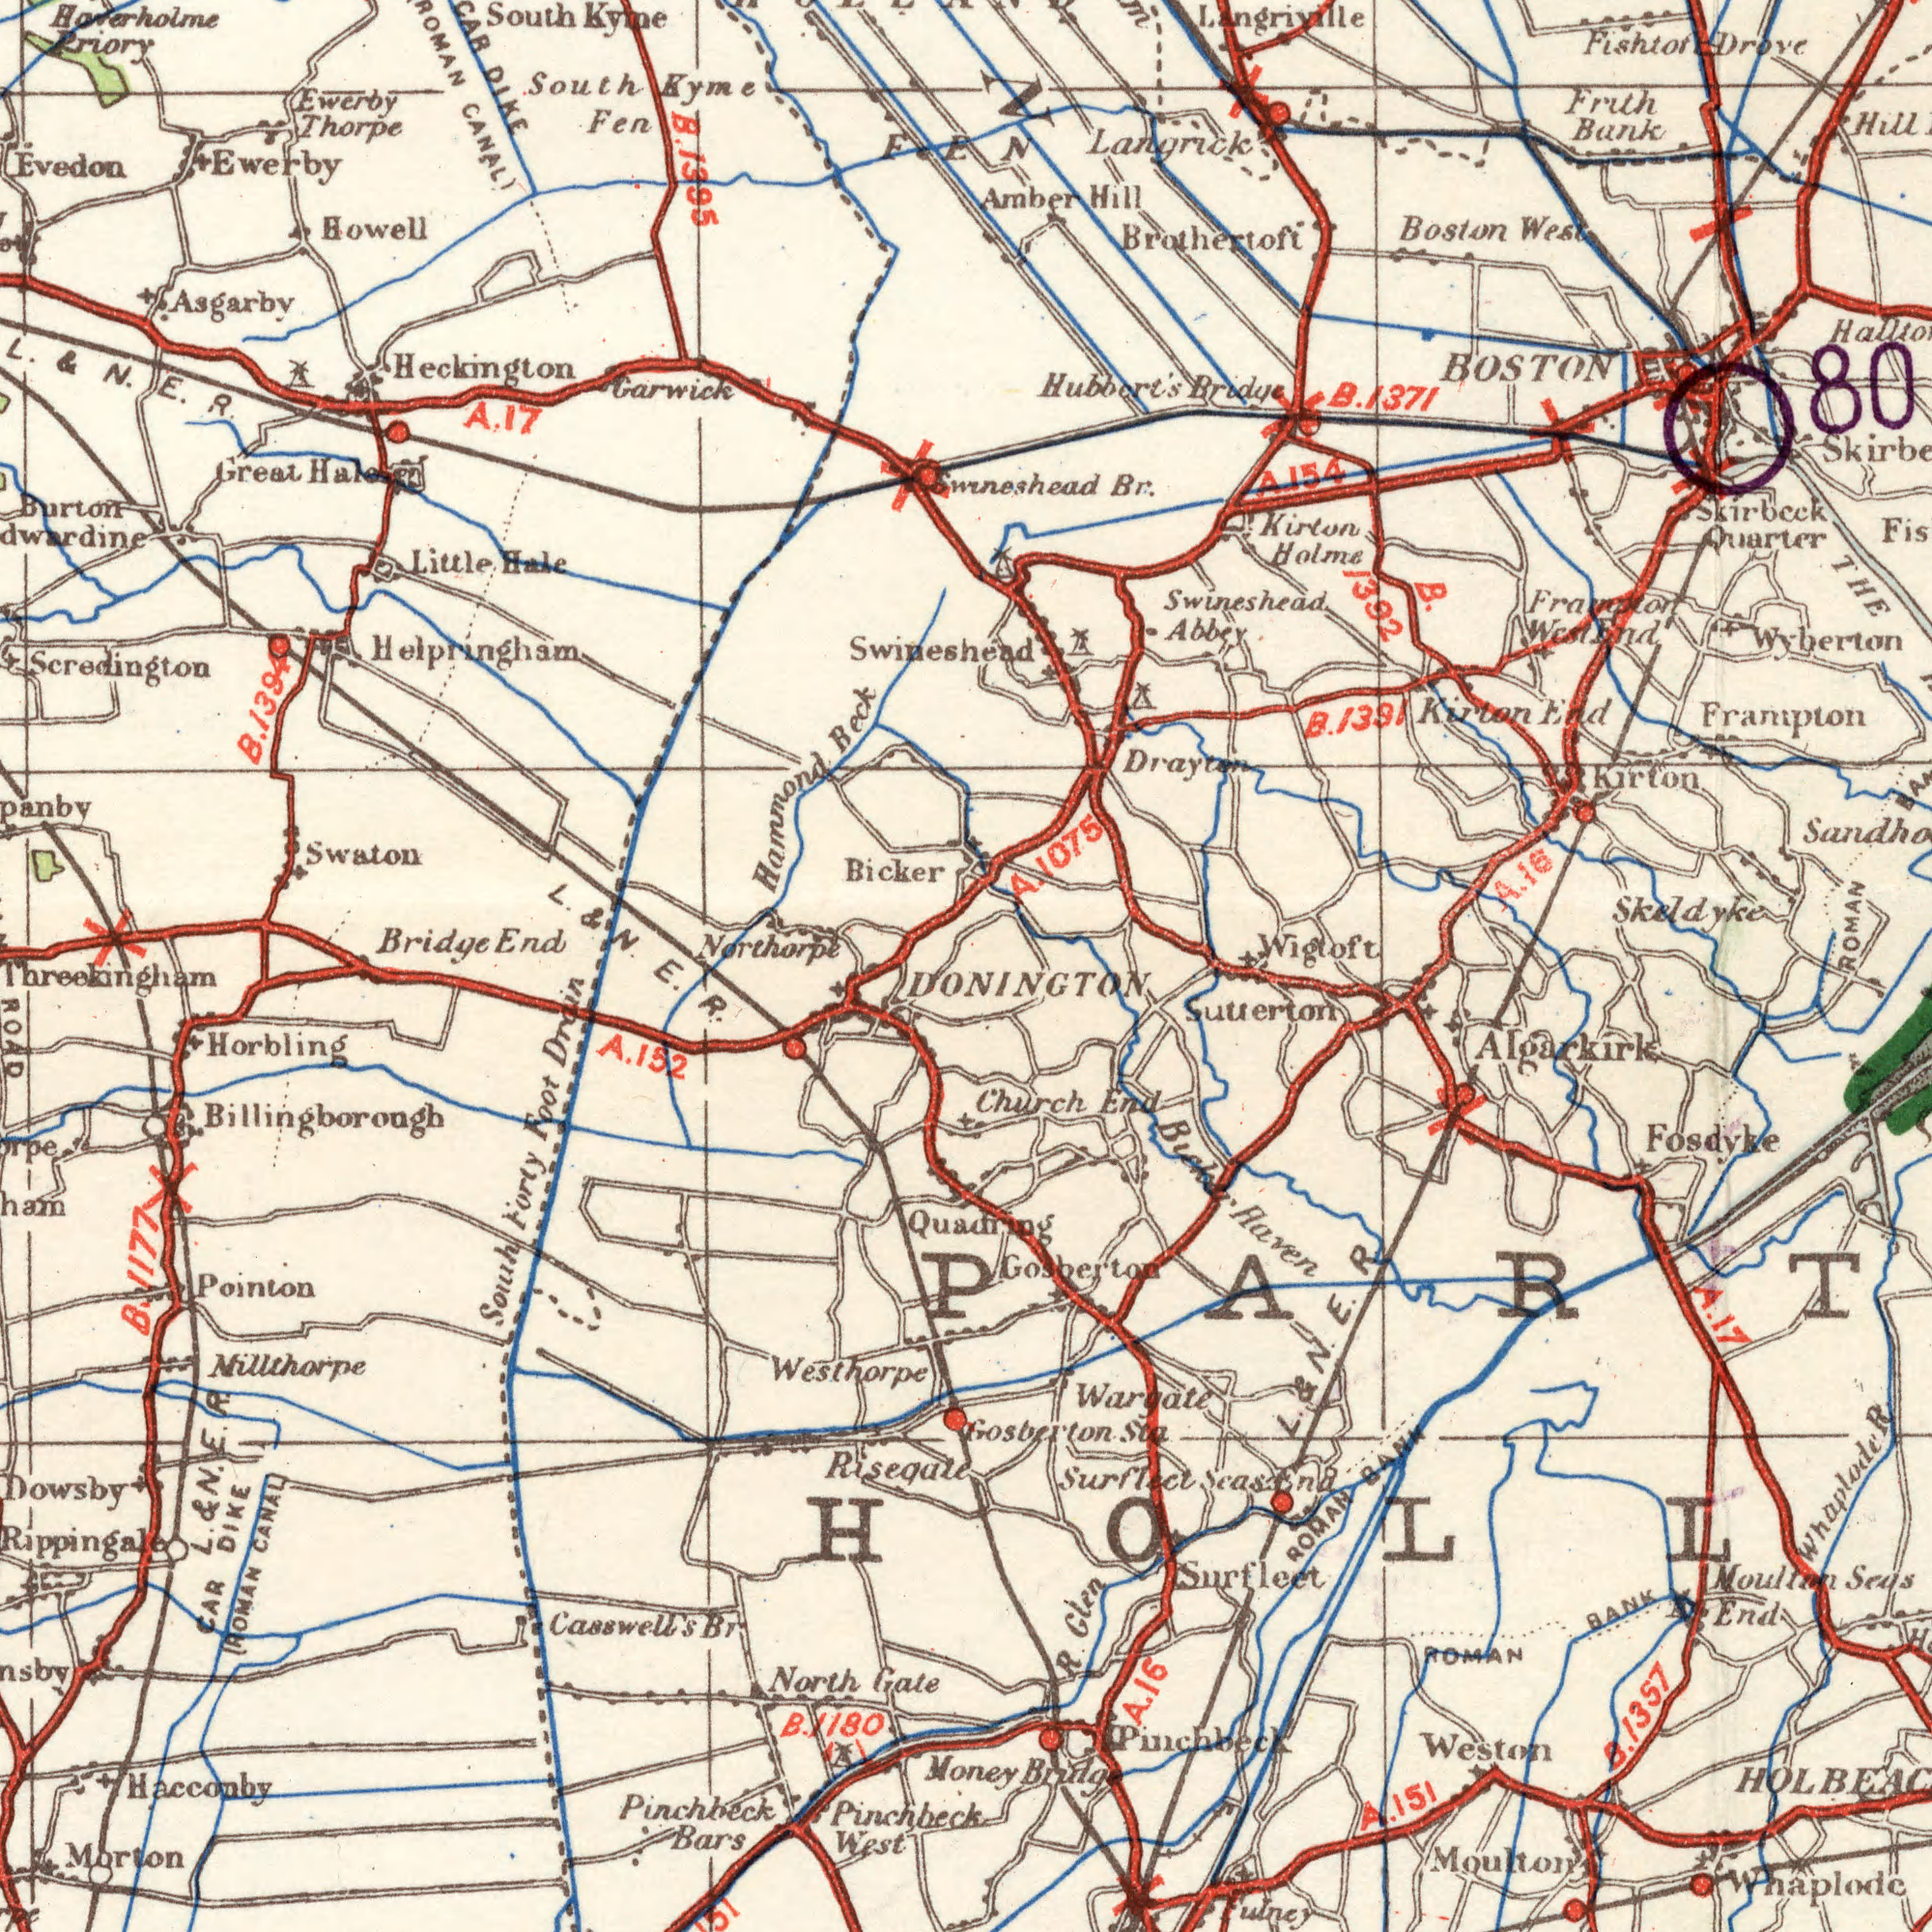What text can you see in the bottom-left section? E. R. Pinchbeck West. Morton Nillthorpe CAR DIKE ROMAN CANAL Horbling Dowsby Pointon Rippingale Pinchbeck Bars South Forty Foot Drain Westhorpe ROAD B. Gate 1180 Casswell's Br Hacconby Threekingham Billingborough Riseqale A. 152 L. & N. E. R. B. 1177 What text appears in the top-right area of the image? Frampton Brothertoft Swineshead Abbey Kirton End Wyberton Boston West Frith Bank Kirton BOSTON Swineshead Br. ROMAN B. 1392 Amber Hill Langrick Fishtoft Drove Kirton Holme Skirbcck Quarter Hubbert's Bridge Wigtoft THE 80 Drayten Framton West End Langriville Skeldyke A. 1075 A. 154 B. 1391 A. 16 B. 1371 ###N What text can you see in the bottom-right section? Moulton Wargate Gosberton. Sta Algarkirk Church End Haven Sutlerton Fosdyke Money Bridg R. Glen Weston B. 1357 Whaplode Pinchbeck Moultan Seus End ROMAN BANK ulney L. & N. E. R ROMAN BANK Surflect Season A. 17 A. 16 A. 151 DONINGTON Quadring Gosberton Sur Fleet What text can you see in the top-left section? Scredington South Kyme Bicker Swaton Bridge End Heckington Garwick South Kyine Hammond Beck Howell Evedon Great Hale Ewerby Thorpe Fen CAR DIKE Little Hale L. & N. E. R. Ewerby Northorpe Burton Hoterholme Priory Asgarby Helpringham L. & N. B. 1395 A. 17 B. 1394 FEN Swineshead ROMAN CANAL) 